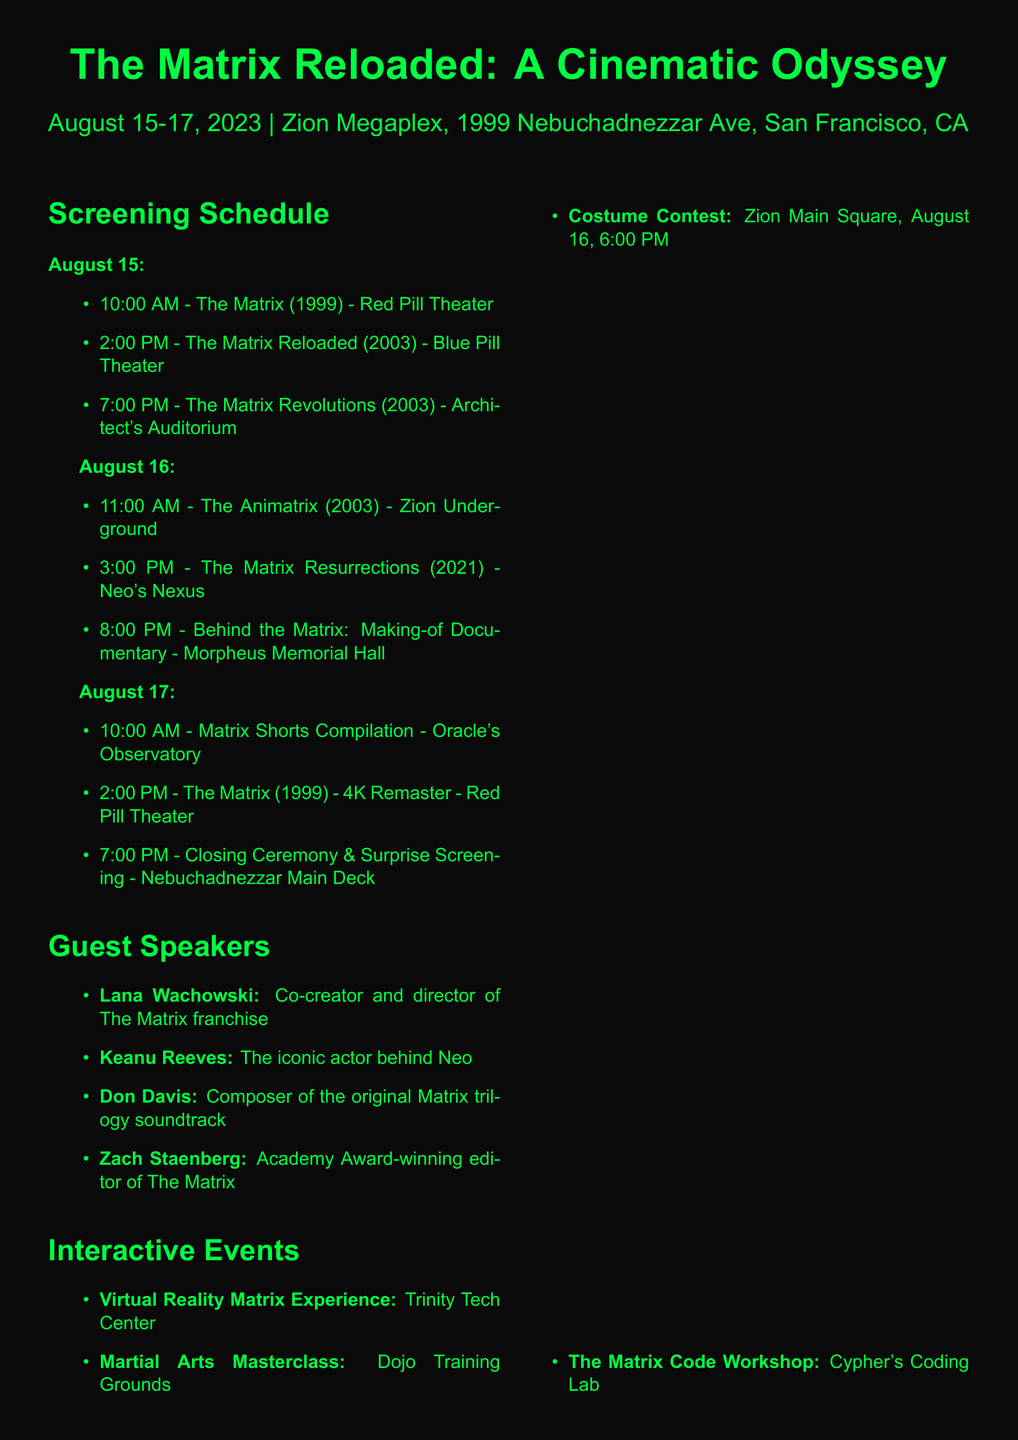what is the name of the film festival? The name of the film festival is provided at the beginning of the document.
Answer: The Matrix Reloaded: A Cinematic Odyssey what are the dates of the festival? The dates of the festival are specified in the opening section of the document.
Answer: August 15-17, 2023 who is the keynote speaker? The keynote speaker is listed under the guest speakers section with their corresponding event title.
Answer: Lana Wachowski how many films are being screened on August 16? By counting the entries in the screening schedule for August 16, we can find the number of films.
Answer: 3 what is the location of the Martial Arts Masterclass? The location for the Martial Arts Masterclass is listed in the interactive events section.
Answer: Dojo Training Grounds what time is the costume contest held? The time of the costume contest is explicitly stated in the interactive events section.
Answer: August 16, 6:00 PM what is the name of the café mentioned in the food and drinks section? The document lists the names of the food and drink options available at the festival.
Answer: Tasty Wheat Cafe what is the main theme of the festival? The theme is implied by the festival title and the films included in the screening schedule.
Answer: The Matrix who created the original soundtrack for The Matrix trilogy? This information is found in the guest speakers section where the speakers’ bios are listed.
Answer: Don Davis 